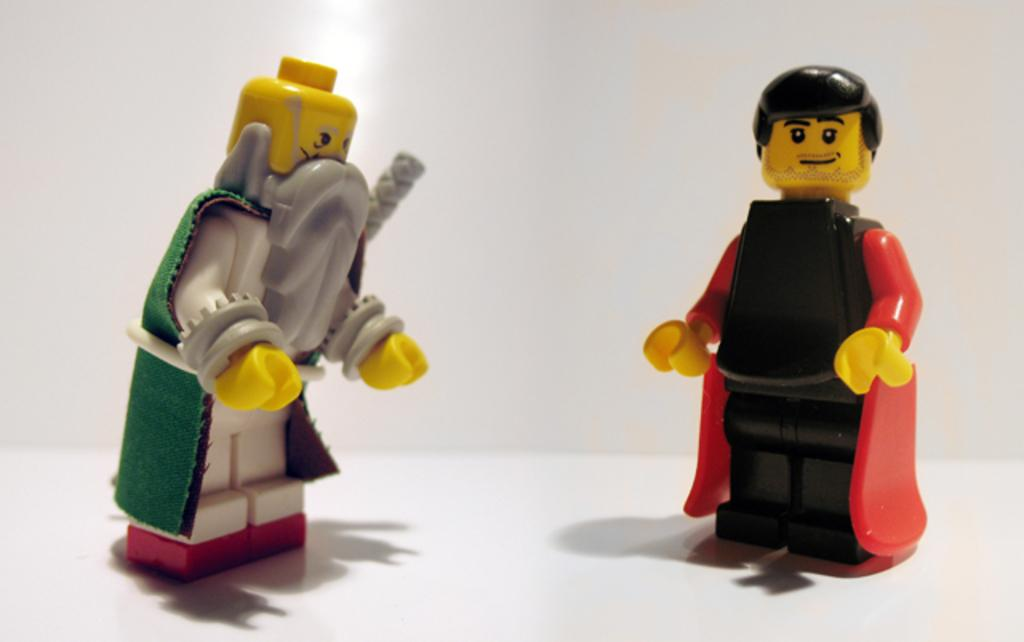How many toys are present in the image? There are two toys in the image. What colors can be seen on the toys? The toys have green, grey, red, and black colors. What is the color of the background in the image? The background of the image is white. What part of the image shares the same color as the background? The bottom part of the image is white. Is the water level increasing in the image? There is no water present in the image, so it is not possible to determine if the water level is increasing. 